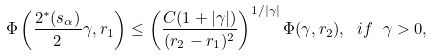<formula> <loc_0><loc_0><loc_500><loc_500>\Phi \left ( \frac { 2 ^ { * } ( s _ { \alpha } ) } { 2 } \gamma , r _ { 1 } \right ) \leq \left ( \frac { C ( 1 + | \gamma | ) } { ( r _ { 2 } - r _ { 1 } ) ^ { 2 } } \right ) ^ { 1 / | \gamma | } \Phi ( \gamma , r _ { 2 } ) , \ i f \ \gamma > 0 ,</formula> 